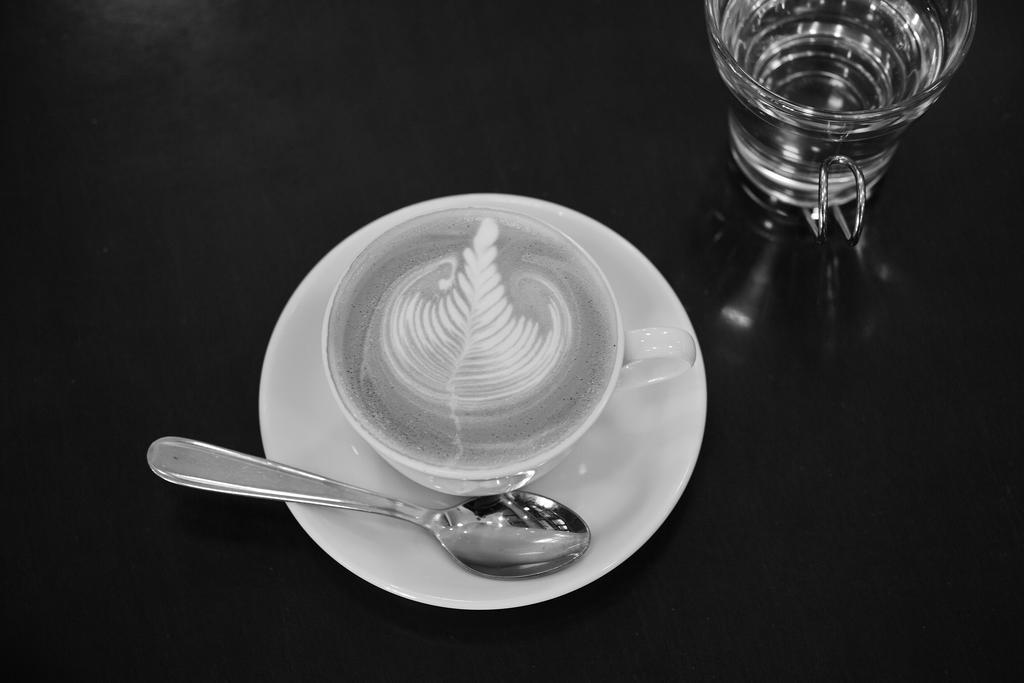Can you describe this image briefly? In the picture I can see a glass, a cup and a spoon on a white color saucer. These objects are on a black color surface. 